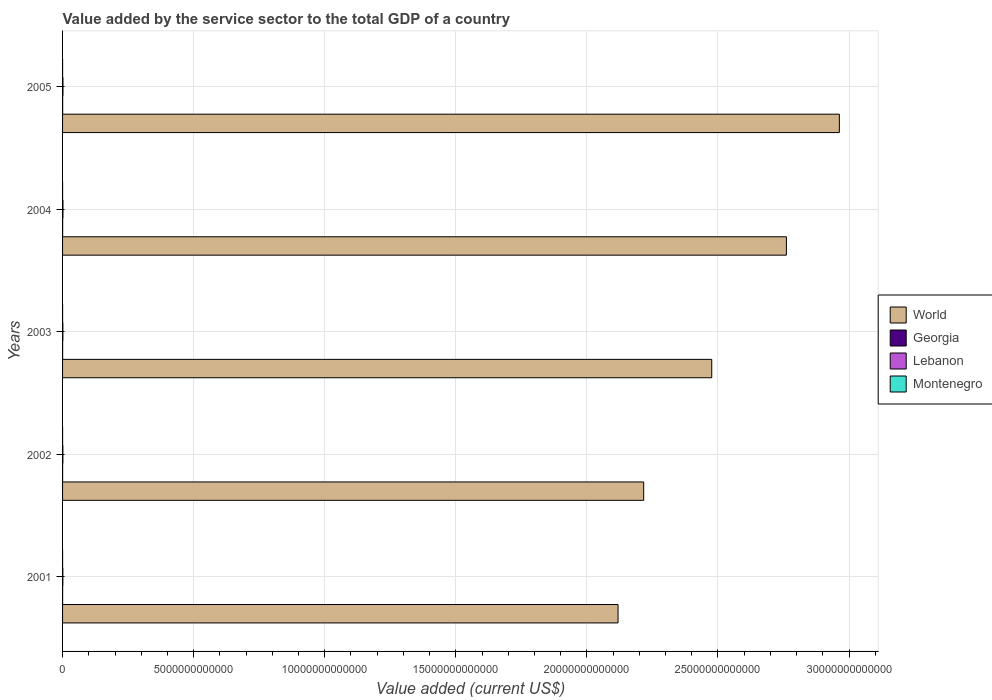How many groups of bars are there?
Offer a terse response. 5. Are the number of bars on each tick of the Y-axis equal?
Your answer should be very brief. Yes. How many bars are there on the 1st tick from the top?
Give a very brief answer. 4. How many bars are there on the 4th tick from the bottom?
Offer a very short reply. 4. What is the label of the 2nd group of bars from the top?
Give a very brief answer. 2004. In how many cases, is the number of bars for a given year not equal to the number of legend labels?
Provide a succinct answer. 0. What is the value added by the service sector to the total GDP in Georgia in 2001?
Your answer should be compact. 1.67e+09. Across all years, what is the maximum value added by the service sector to the total GDP in Georgia?
Offer a very short reply. 3.20e+09. Across all years, what is the minimum value added by the service sector to the total GDP in Lebanon?
Ensure brevity in your answer.  1.08e+1. In which year was the value added by the service sector to the total GDP in Lebanon maximum?
Keep it short and to the point. 2005. In which year was the value added by the service sector to the total GDP in Georgia minimum?
Provide a succinct answer. 2001. What is the total value added by the service sector to the total GDP in Lebanon in the graph?
Offer a very short reply. 6.41e+1. What is the difference between the value added by the service sector to the total GDP in Montenegro in 2001 and that in 2002?
Keep it short and to the point. -6.78e+07. What is the difference between the value added by the service sector to the total GDP in Lebanon in 2004 and the value added by the service sector to the total GDP in Montenegro in 2003?
Offer a terse response. 1.36e+1. What is the average value added by the service sector to the total GDP in Lebanon per year?
Ensure brevity in your answer.  1.28e+1. In the year 2002, what is the difference between the value added by the service sector to the total GDP in Lebanon and value added by the service sector to the total GDP in Montenegro?
Make the answer very short. 1.08e+1. In how many years, is the value added by the service sector to the total GDP in Montenegro greater than 19000000000000 US$?
Make the answer very short. 0. What is the ratio of the value added by the service sector to the total GDP in World in 2004 to that in 2005?
Your answer should be very brief. 0.93. What is the difference between the highest and the second highest value added by the service sector to the total GDP in World?
Make the answer very short. 2.02e+12. What is the difference between the highest and the lowest value added by the service sector to the total GDP in World?
Keep it short and to the point. 8.44e+12. In how many years, is the value added by the service sector to the total GDP in Lebanon greater than the average value added by the service sector to the total GDP in Lebanon taken over all years?
Your answer should be compact. 2. Is it the case that in every year, the sum of the value added by the service sector to the total GDP in World and value added by the service sector to the total GDP in Lebanon is greater than the sum of value added by the service sector to the total GDP in Montenegro and value added by the service sector to the total GDP in Georgia?
Ensure brevity in your answer.  Yes. What does the 4th bar from the bottom in 2003 represents?
Your response must be concise. Montenegro. How many bars are there?
Provide a succinct answer. 20. Are all the bars in the graph horizontal?
Provide a short and direct response. Yes. What is the difference between two consecutive major ticks on the X-axis?
Offer a terse response. 5.00e+12. Does the graph contain grids?
Make the answer very short. Yes. Where does the legend appear in the graph?
Your answer should be very brief. Center right. What is the title of the graph?
Your response must be concise. Value added by the service sector to the total GDP of a country. Does "Eritrea" appear as one of the legend labels in the graph?
Make the answer very short. No. What is the label or title of the X-axis?
Ensure brevity in your answer.  Value added (current US$). What is the label or title of the Y-axis?
Your response must be concise. Years. What is the Value added (current US$) of World in 2001?
Make the answer very short. 2.12e+13. What is the Value added (current US$) in Georgia in 2001?
Ensure brevity in your answer.  1.67e+09. What is the Value added (current US$) in Lebanon in 2001?
Provide a short and direct response. 1.08e+1. What is the Value added (current US$) of Montenegro in 2001?
Provide a short and direct response. 6.65e+08. What is the Value added (current US$) in World in 2002?
Keep it short and to the point. 2.22e+13. What is the Value added (current US$) of Georgia in 2002?
Offer a very short reply. 1.74e+09. What is the Value added (current US$) of Lebanon in 2002?
Give a very brief answer. 1.15e+1. What is the Value added (current US$) of Montenegro in 2002?
Offer a very short reply. 7.33e+08. What is the Value added (current US$) in World in 2003?
Your answer should be very brief. 2.48e+13. What is the Value added (current US$) in Georgia in 2003?
Offer a terse response. 2.02e+09. What is the Value added (current US$) of Lebanon in 2003?
Offer a very short reply. 1.20e+1. What is the Value added (current US$) in Montenegro in 2003?
Make the answer very short. 9.59e+08. What is the Value added (current US$) in World in 2004?
Ensure brevity in your answer.  2.76e+13. What is the Value added (current US$) of Georgia in 2004?
Your answer should be compact. 2.61e+09. What is the Value added (current US$) in Lebanon in 2004?
Provide a short and direct response. 1.45e+1. What is the Value added (current US$) in Montenegro in 2004?
Offer a terse response. 1.18e+09. What is the Value added (current US$) in World in 2005?
Give a very brief answer. 2.96e+13. What is the Value added (current US$) in Georgia in 2005?
Offer a terse response. 3.20e+09. What is the Value added (current US$) in Lebanon in 2005?
Provide a short and direct response. 1.52e+1. What is the Value added (current US$) in Montenegro in 2005?
Make the answer very short. 1.30e+09. Across all years, what is the maximum Value added (current US$) of World?
Provide a succinct answer. 2.96e+13. Across all years, what is the maximum Value added (current US$) of Georgia?
Provide a succinct answer. 3.20e+09. Across all years, what is the maximum Value added (current US$) of Lebanon?
Give a very brief answer. 1.52e+1. Across all years, what is the maximum Value added (current US$) of Montenegro?
Offer a terse response. 1.30e+09. Across all years, what is the minimum Value added (current US$) of World?
Offer a terse response. 2.12e+13. Across all years, what is the minimum Value added (current US$) in Georgia?
Provide a succinct answer. 1.67e+09. Across all years, what is the minimum Value added (current US$) in Lebanon?
Offer a terse response. 1.08e+1. Across all years, what is the minimum Value added (current US$) in Montenegro?
Your answer should be compact. 6.65e+08. What is the total Value added (current US$) in World in the graph?
Your response must be concise. 1.25e+14. What is the total Value added (current US$) of Georgia in the graph?
Ensure brevity in your answer.  1.12e+1. What is the total Value added (current US$) in Lebanon in the graph?
Offer a very short reply. 6.41e+1. What is the total Value added (current US$) of Montenegro in the graph?
Ensure brevity in your answer.  4.84e+09. What is the difference between the Value added (current US$) of World in 2001 and that in 2002?
Provide a short and direct response. -9.78e+11. What is the difference between the Value added (current US$) of Georgia in 2001 and that in 2002?
Ensure brevity in your answer.  -7.15e+07. What is the difference between the Value added (current US$) of Lebanon in 2001 and that in 2002?
Make the answer very short. -6.78e+08. What is the difference between the Value added (current US$) of Montenegro in 2001 and that in 2002?
Provide a short and direct response. -6.78e+07. What is the difference between the Value added (current US$) of World in 2001 and that in 2003?
Provide a short and direct response. -3.57e+12. What is the difference between the Value added (current US$) in Georgia in 2001 and that in 2003?
Make the answer very short. -3.43e+08. What is the difference between the Value added (current US$) of Lebanon in 2001 and that in 2003?
Offer a very short reply. -1.12e+09. What is the difference between the Value added (current US$) in Montenegro in 2001 and that in 2003?
Provide a succinct answer. -2.94e+08. What is the difference between the Value added (current US$) of World in 2001 and that in 2004?
Your answer should be very brief. -6.42e+12. What is the difference between the Value added (current US$) in Georgia in 2001 and that in 2004?
Keep it short and to the point. -9.37e+08. What is the difference between the Value added (current US$) in Lebanon in 2001 and that in 2004?
Your response must be concise. -3.69e+09. What is the difference between the Value added (current US$) in Montenegro in 2001 and that in 2004?
Keep it short and to the point. -5.14e+08. What is the difference between the Value added (current US$) in World in 2001 and that in 2005?
Ensure brevity in your answer.  -8.44e+12. What is the difference between the Value added (current US$) of Georgia in 2001 and that in 2005?
Offer a very short reply. -1.53e+09. What is the difference between the Value added (current US$) in Lebanon in 2001 and that in 2005?
Offer a very short reply. -4.37e+09. What is the difference between the Value added (current US$) in Montenegro in 2001 and that in 2005?
Your answer should be very brief. -6.36e+08. What is the difference between the Value added (current US$) of World in 2002 and that in 2003?
Offer a very short reply. -2.60e+12. What is the difference between the Value added (current US$) of Georgia in 2002 and that in 2003?
Offer a very short reply. -2.72e+08. What is the difference between the Value added (current US$) of Lebanon in 2002 and that in 2003?
Keep it short and to the point. -4.43e+08. What is the difference between the Value added (current US$) in Montenegro in 2002 and that in 2003?
Your answer should be very brief. -2.26e+08. What is the difference between the Value added (current US$) in World in 2002 and that in 2004?
Give a very brief answer. -5.44e+12. What is the difference between the Value added (current US$) in Georgia in 2002 and that in 2004?
Keep it short and to the point. -8.66e+08. What is the difference between the Value added (current US$) in Lebanon in 2002 and that in 2004?
Provide a succinct answer. -3.01e+09. What is the difference between the Value added (current US$) in Montenegro in 2002 and that in 2004?
Give a very brief answer. -4.46e+08. What is the difference between the Value added (current US$) of World in 2002 and that in 2005?
Your answer should be compact. -7.46e+12. What is the difference between the Value added (current US$) in Georgia in 2002 and that in 2005?
Ensure brevity in your answer.  -1.46e+09. What is the difference between the Value added (current US$) of Lebanon in 2002 and that in 2005?
Provide a short and direct response. -3.69e+09. What is the difference between the Value added (current US$) of Montenegro in 2002 and that in 2005?
Ensure brevity in your answer.  -5.68e+08. What is the difference between the Value added (current US$) in World in 2003 and that in 2004?
Provide a succinct answer. -2.85e+12. What is the difference between the Value added (current US$) in Georgia in 2003 and that in 2004?
Your answer should be compact. -5.94e+08. What is the difference between the Value added (current US$) of Lebanon in 2003 and that in 2004?
Provide a succinct answer. -2.57e+09. What is the difference between the Value added (current US$) in Montenegro in 2003 and that in 2004?
Provide a short and direct response. -2.20e+08. What is the difference between the Value added (current US$) in World in 2003 and that in 2005?
Your answer should be compact. -4.87e+12. What is the difference between the Value added (current US$) in Georgia in 2003 and that in 2005?
Make the answer very short. -1.19e+09. What is the difference between the Value added (current US$) in Lebanon in 2003 and that in 2005?
Give a very brief answer. -3.24e+09. What is the difference between the Value added (current US$) of Montenegro in 2003 and that in 2005?
Give a very brief answer. -3.42e+08. What is the difference between the Value added (current US$) of World in 2004 and that in 2005?
Make the answer very short. -2.02e+12. What is the difference between the Value added (current US$) in Georgia in 2004 and that in 2005?
Keep it short and to the point. -5.93e+08. What is the difference between the Value added (current US$) of Lebanon in 2004 and that in 2005?
Your response must be concise. -6.77e+08. What is the difference between the Value added (current US$) of Montenegro in 2004 and that in 2005?
Ensure brevity in your answer.  -1.22e+08. What is the difference between the Value added (current US$) of World in 2001 and the Value added (current US$) of Georgia in 2002?
Offer a terse response. 2.12e+13. What is the difference between the Value added (current US$) in World in 2001 and the Value added (current US$) in Lebanon in 2002?
Your answer should be compact. 2.12e+13. What is the difference between the Value added (current US$) in World in 2001 and the Value added (current US$) in Montenegro in 2002?
Offer a very short reply. 2.12e+13. What is the difference between the Value added (current US$) in Georgia in 2001 and the Value added (current US$) in Lebanon in 2002?
Offer a very short reply. -9.85e+09. What is the difference between the Value added (current US$) of Georgia in 2001 and the Value added (current US$) of Montenegro in 2002?
Offer a very short reply. 9.40e+08. What is the difference between the Value added (current US$) of Lebanon in 2001 and the Value added (current US$) of Montenegro in 2002?
Give a very brief answer. 1.01e+1. What is the difference between the Value added (current US$) in World in 2001 and the Value added (current US$) in Georgia in 2003?
Make the answer very short. 2.12e+13. What is the difference between the Value added (current US$) in World in 2001 and the Value added (current US$) in Lebanon in 2003?
Offer a terse response. 2.12e+13. What is the difference between the Value added (current US$) of World in 2001 and the Value added (current US$) of Montenegro in 2003?
Make the answer very short. 2.12e+13. What is the difference between the Value added (current US$) of Georgia in 2001 and the Value added (current US$) of Lebanon in 2003?
Offer a very short reply. -1.03e+1. What is the difference between the Value added (current US$) of Georgia in 2001 and the Value added (current US$) of Montenegro in 2003?
Your response must be concise. 7.14e+08. What is the difference between the Value added (current US$) of Lebanon in 2001 and the Value added (current US$) of Montenegro in 2003?
Offer a very short reply. 9.88e+09. What is the difference between the Value added (current US$) in World in 2001 and the Value added (current US$) in Georgia in 2004?
Your answer should be very brief. 2.12e+13. What is the difference between the Value added (current US$) in World in 2001 and the Value added (current US$) in Lebanon in 2004?
Provide a short and direct response. 2.12e+13. What is the difference between the Value added (current US$) of World in 2001 and the Value added (current US$) of Montenegro in 2004?
Keep it short and to the point. 2.12e+13. What is the difference between the Value added (current US$) in Georgia in 2001 and the Value added (current US$) in Lebanon in 2004?
Ensure brevity in your answer.  -1.29e+1. What is the difference between the Value added (current US$) of Georgia in 2001 and the Value added (current US$) of Montenegro in 2004?
Your answer should be compact. 4.94e+08. What is the difference between the Value added (current US$) in Lebanon in 2001 and the Value added (current US$) in Montenegro in 2004?
Your answer should be very brief. 9.66e+09. What is the difference between the Value added (current US$) in World in 2001 and the Value added (current US$) in Georgia in 2005?
Provide a short and direct response. 2.12e+13. What is the difference between the Value added (current US$) of World in 2001 and the Value added (current US$) of Lebanon in 2005?
Provide a short and direct response. 2.12e+13. What is the difference between the Value added (current US$) in World in 2001 and the Value added (current US$) in Montenegro in 2005?
Keep it short and to the point. 2.12e+13. What is the difference between the Value added (current US$) in Georgia in 2001 and the Value added (current US$) in Lebanon in 2005?
Your response must be concise. -1.35e+1. What is the difference between the Value added (current US$) of Georgia in 2001 and the Value added (current US$) of Montenegro in 2005?
Your answer should be compact. 3.72e+08. What is the difference between the Value added (current US$) in Lebanon in 2001 and the Value added (current US$) in Montenegro in 2005?
Provide a succinct answer. 9.54e+09. What is the difference between the Value added (current US$) in World in 2002 and the Value added (current US$) in Georgia in 2003?
Make the answer very short. 2.22e+13. What is the difference between the Value added (current US$) in World in 2002 and the Value added (current US$) in Lebanon in 2003?
Give a very brief answer. 2.22e+13. What is the difference between the Value added (current US$) in World in 2002 and the Value added (current US$) in Montenegro in 2003?
Your answer should be very brief. 2.22e+13. What is the difference between the Value added (current US$) of Georgia in 2002 and the Value added (current US$) of Lebanon in 2003?
Give a very brief answer. -1.02e+1. What is the difference between the Value added (current US$) in Georgia in 2002 and the Value added (current US$) in Montenegro in 2003?
Provide a succinct answer. 7.85e+08. What is the difference between the Value added (current US$) in Lebanon in 2002 and the Value added (current US$) in Montenegro in 2003?
Offer a very short reply. 1.06e+1. What is the difference between the Value added (current US$) in World in 2002 and the Value added (current US$) in Georgia in 2004?
Ensure brevity in your answer.  2.22e+13. What is the difference between the Value added (current US$) of World in 2002 and the Value added (current US$) of Lebanon in 2004?
Your response must be concise. 2.22e+13. What is the difference between the Value added (current US$) in World in 2002 and the Value added (current US$) in Montenegro in 2004?
Your response must be concise. 2.22e+13. What is the difference between the Value added (current US$) in Georgia in 2002 and the Value added (current US$) in Lebanon in 2004?
Keep it short and to the point. -1.28e+1. What is the difference between the Value added (current US$) of Georgia in 2002 and the Value added (current US$) of Montenegro in 2004?
Your answer should be compact. 5.65e+08. What is the difference between the Value added (current US$) in Lebanon in 2002 and the Value added (current US$) in Montenegro in 2004?
Ensure brevity in your answer.  1.03e+1. What is the difference between the Value added (current US$) in World in 2002 and the Value added (current US$) in Georgia in 2005?
Offer a very short reply. 2.22e+13. What is the difference between the Value added (current US$) in World in 2002 and the Value added (current US$) in Lebanon in 2005?
Ensure brevity in your answer.  2.22e+13. What is the difference between the Value added (current US$) of World in 2002 and the Value added (current US$) of Montenegro in 2005?
Your answer should be compact. 2.22e+13. What is the difference between the Value added (current US$) of Georgia in 2002 and the Value added (current US$) of Lebanon in 2005?
Offer a very short reply. -1.35e+1. What is the difference between the Value added (current US$) of Georgia in 2002 and the Value added (current US$) of Montenegro in 2005?
Give a very brief answer. 4.43e+08. What is the difference between the Value added (current US$) in Lebanon in 2002 and the Value added (current US$) in Montenegro in 2005?
Make the answer very short. 1.02e+1. What is the difference between the Value added (current US$) in World in 2003 and the Value added (current US$) in Georgia in 2004?
Your answer should be compact. 2.48e+13. What is the difference between the Value added (current US$) in World in 2003 and the Value added (current US$) in Lebanon in 2004?
Provide a short and direct response. 2.47e+13. What is the difference between the Value added (current US$) in World in 2003 and the Value added (current US$) in Montenegro in 2004?
Provide a short and direct response. 2.48e+13. What is the difference between the Value added (current US$) of Georgia in 2003 and the Value added (current US$) of Lebanon in 2004?
Make the answer very short. -1.25e+1. What is the difference between the Value added (current US$) in Georgia in 2003 and the Value added (current US$) in Montenegro in 2004?
Keep it short and to the point. 8.37e+08. What is the difference between the Value added (current US$) of Lebanon in 2003 and the Value added (current US$) of Montenegro in 2004?
Offer a terse response. 1.08e+1. What is the difference between the Value added (current US$) of World in 2003 and the Value added (current US$) of Georgia in 2005?
Your answer should be very brief. 2.48e+13. What is the difference between the Value added (current US$) of World in 2003 and the Value added (current US$) of Lebanon in 2005?
Offer a very short reply. 2.47e+13. What is the difference between the Value added (current US$) in World in 2003 and the Value added (current US$) in Montenegro in 2005?
Your answer should be compact. 2.48e+13. What is the difference between the Value added (current US$) in Georgia in 2003 and the Value added (current US$) in Lebanon in 2005?
Your answer should be compact. -1.32e+1. What is the difference between the Value added (current US$) in Georgia in 2003 and the Value added (current US$) in Montenegro in 2005?
Offer a terse response. 7.15e+08. What is the difference between the Value added (current US$) of Lebanon in 2003 and the Value added (current US$) of Montenegro in 2005?
Offer a terse response. 1.07e+1. What is the difference between the Value added (current US$) of World in 2004 and the Value added (current US$) of Georgia in 2005?
Give a very brief answer. 2.76e+13. What is the difference between the Value added (current US$) in World in 2004 and the Value added (current US$) in Lebanon in 2005?
Offer a terse response. 2.76e+13. What is the difference between the Value added (current US$) in World in 2004 and the Value added (current US$) in Montenegro in 2005?
Keep it short and to the point. 2.76e+13. What is the difference between the Value added (current US$) of Georgia in 2004 and the Value added (current US$) of Lebanon in 2005?
Your answer should be very brief. -1.26e+1. What is the difference between the Value added (current US$) in Georgia in 2004 and the Value added (current US$) in Montenegro in 2005?
Provide a short and direct response. 1.31e+09. What is the difference between the Value added (current US$) of Lebanon in 2004 and the Value added (current US$) of Montenegro in 2005?
Provide a succinct answer. 1.32e+1. What is the average Value added (current US$) in World per year?
Ensure brevity in your answer.  2.51e+13. What is the average Value added (current US$) of Georgia per year?
Your answer should be compact. 2.25e+09. What is the average Value added (current US$) in Lebanon per year?
Provide a succinct answer. 1.28e+1. What is the average Value added (current US$) of Montenegro per year?
Offer a very short reply. 9.68e+08. In the year 2001, what is the difference between the Value added (current US$) of World and Value added (current US$) of Georgia?
Keep it short and to the point. 2.12e+13. In the year 2001, what is the difference between the Value added (current US$) in World and Value added (current US$) in Lebanon?
Provide a short and direct response. 2.12e+13. In the year 2001, what is the difference between the Value added (current US$) in World and Value added (current US$) in Montenegro?
Provide a succinct answer. 2.12e+13. In the year 2001, what is the difference between the Value added (current US$) of Georgia and Value added (current US$) of Lebanon?
Make the answer very short. -9.17e+09. In the year 2001, what is the difference between the Value added (current US$) of Georgia and Value added (current US$) of Montenegro?
Provide a short and direct response. 1.01e+09. In the year 2001, what is the difference between the Value added (current US$) of Lebanon and Value added (current US$) of Montenegro?
Offer a very short reply. 1.02e+1. In the year 2002, what is the difference between the Value added (current US$) of World and Value added (current US$) of Georgia?
Offer a terse response. 2.22e+13. In the year 2002, what is the difference between the Value added (current US$) in World and Value added (current US$) in Lebanon?
Offer a very short reply. 2.22e+13. In the year 2002, what is the difference between the Value added (current US$) in World and Value added (current US$) in Montenegro?
Make the answer very short. 2.22e+13. In the year 2002, what is the difference between the Value added (current US$) in Georgia and Value added (current US$) in Lebanon?
Provide a short and direct response. -9.78e+09. In the year 2002, what is the difference between the Value added (current US$) in Georgia and Value added (current US$) in Montenegro?
Give a very brief answer. 1.01e+09. In the year 2002, what is the difference between the Value added (current US$) in Lebanon and Value added (current US$) in Montenegro?
Your answer should be compact. 1.08e+1. In the year 2003, what is the difference between the Value added (current US$) in World and Value added (current US$) in Georgia?
Your answer should be very brief. 2.48e+13. In the year 2003, what is the difference between the Value added (current US$) of World and Value added (current US$) of Lebanon?
Give a very brief answer. 2.48e+13. In the year 2003, what is the difference between the Value added (current US$) of World and Value added (current US$) of Montenegro?
Offer a very short reply. 2.48e+13. In the year 2003, what is the difference between the Value added (current US$) of Georgia and Value added (current US$) of Lebanon?
Keep it short and to the point. -9.95e+09. In the year 2003, what is the difference between the Value added (current US$) of Georgia and Value added (current US$) of Montenegro?
Offer a terse response. 1.06e+09. In the year 2003, what is the difference between the Value added (current US$) in Lebanon and Value added (current US$) in Montenegro?
Your response must be concise. 1.10e+1. In the year 2004, what is the difference between the Value added (current US$) of World and Value added (current US$) of Georgia?
Give a very brief answer. 2.76e+13. In the year 2004, what is the difference between the Value added (current US$) in World and Value added (current US$) in Lebanon?
Your response must be concise. 2.76e+13. In the year 2004, what is the difference between the Value added (current US$) of World and Value added (current US$) of Montenegro?
Give a very brief answer. 2.76e+13. In the year 2004, what is the difference between the Value added (current US$) in Georgia and Value added (current US$) in Lebanon?
Give a very brief answer. -1.19e+1. In the year 2004, what is the difference between the Value added (current US$) of Georgia and Value added (current US$) of Montenegro?
Your answer should be compact. 1.43e+09. In the year 2004, what is the difference between the Value added (current US$) in Lebanon and Value added (current US$) in Montenegro?
Your answer should be very brief. 1.34e+1. In the year 2005, what is the difference between the Value added (current US$) of World and Value added (current US$) of Georgia?
Ensure brevity in your answer.  2.96e+13. In the year 2005, what is the difference between the Value added (current US$) in World and Value added (current US$) in Lebanon?
Give a very brief answer. 2.96e+13. In the year 2005, what is the difference between the Value added (current US$) of World and Value added (current US$) of Montenegro?
Give a very brief answer. 2.96e+13. In the year 2005, what is the difference between the Value added (current US$) of Georgia and Value added (current US$) of Lebanon?
Make the answer very short. -1.20e+1. In the year 2005, what is the difference between the Value added (current US$) in Georgia and Value added (current US$) in Montenegro?
Your answer should be very brief. 1.90e+09. In the year 2005, what is the difference between the Value added (current US$) of Lebanon and Value added (current US$) of Montenegro?
Ensure brevity in your answer.  1.39e+1. What is the ratio of the Value added (current US$) of World in 2001 to that in 2002?
Give a very brief answer. 0.96. What is the ratio of the Value added (current US$) in Georgia in 2001 to that in 2002?
Give a very brief answer. 0.96. What is the ratio of the Value added (current US$) in Lebanon in 2001 to that in 2002?
Provide a short and direct response. 0.94. What is the ratio of the Value added (current US$) in Montenegro in 2001 to that in 2002?
Ensure brevity in your answer.  0.91. What is the ratio of the Value added (current US$) of World in 2001 to that in 2003?
Give a very brief answer. 0.86. What is the ratio of the Value added (current US$) in Georgia in 2001 to that in 2003?
Give a very brief answer. 0.83. What is the ratio of the Value added (current US$) in Lebanon in 2001 to that in 2003?
Offer a very short reply. 0.91. What is the ratio of the Value added (current US$) of Montenegro in 2001 to that in 2003?
Your response must be concise. 0.69. What is the ratio of the Value added (current US$) of World in 2001 to that in 2004?
Ensure brevity in your answer.  0.77. What is the ratio of the Value added (current US$) of Georgia in 2001 to that in 2004?
Provide a short and direct response. 0.64. What is the ratio of the Value added (current US$) of Lebanon in 2001 to that in 2004?
Your response must be concise. 0.75. What is the ratio of the Value added (current US$) in Montenegro in 2001 to that in 2004?
Your response must be concise. 0.56. What is the ratio of the Value added (current US$) of World in 2001 to that in 2005?
Your response must be concise. 0.72. What is the ratio of the Value added (current US$) in Georgia in 2001 to that in 2005?
Ensure brevity in your answer.  0.52. What is the ratio of the Value added (current US$) of Lebanon in 2001 to that in 2005?
Provide a succinct answer. 0.71. What is the ratio of the Value added (current US$) of Montenegro in 2001 to that in 2005?
Ensure brevity in your answer.  0.51. What is the ratio of the Value added (current US$) in World in 2002 to that in 2003?
Your answer should be compact. 0.9. What is the ratio of the Value added (current US$) in Georgia in 2002 to that in 2003?
Provide a short and direct response. 0.87. What is the ratio of the Value added (current US$) of Lebanon in 2002 to that in 2003?
Ensure brevity in your answer.  0.96. What is the ratio of the Value added (current US$) of Montenegro in 2002 to that in 2003?
Provide a short and direct response. 0.76. What is the ratio of the Value added (current US$) of World in 2002 to that in 2004?
Give a very brief answer. 0.8. What is the ratio of the Value added (current US$) in Georgia in 2002 to that in 2004?
Your answer should be very brief. 0.67. What is the ratio of the Value added (current US$) of Lebanon in 2002 to that in 2004?
Make the answer very short. 0.79. What is the ratio of the Value added (current US$) of Montenegro in 2002 to that in 2004?
Offer a terse response. 0.62. What is the ratio of the Value added (current US$) of World in 2002 to that in 2005?
Provide a short and direct response. 0.75. What is the ratio of the Value added (current US$) in Georgia in 2002 to that in 2005?
Ensure brevity in your answer.  0.54. What is the ratio of the Value added (current US$) in Lebanon in 2002 to that in 2005?
Offer a terse response. 0.76. What is the ratio of the Value added (current US$) of Montenegro in 2002 to that in 2005?
Offer a very short reply. 0.56. What is the ratio of the Value added (current US$) of World in 2003 to that in 2004?
Provide a short and direct response. 0.9. What is the ratio of the Value added (current US$) in Georgia in 2003 to that in 2004?
Make the answer very short. 0.77. What is the ratio of the Value added (current US$) of Lebanon in 2003 to that in 2004?
Your response must be concise. 0.82. What is the ratio of the Value added (current US$) in Montenegro in 2003 to that in 2004?
Ensure brevity in your answer.  0.81. What is the ratio of the Value added (current US$) in World in 2003 to that in 2005?
Ensure brevity in your answer.  0.84. What is the ratio of the Value added (current US$) in Georgia in 2003 to that in 2005?
Your response must be concise. 0.63. What is the ratio of the Value added (current US$) in Lebanon in 2003 to that in 2005?
Offer a terse response. 0.79. What is the ratio of the Value added (current US$) in Montenegro in 2003 to that in 2005?
Provide a succinct answer. 0.74. What is the ratio of the Value added (current US$) in World in 2004 to that in 2005?
Provide a succinct answer. 0.93. What is the ratio of the Value added (current US$) in Georgia in 2004 to that in 2005?
Offer a very short reply. 0.81. What is the ratio of the Value added (current US$) of Lebanon in 2004 to that in 2005?
Provide a succinct answer. 0.96. What is the ratio of the Value added (current US$) in Montenegro in 2004 to that in 2005?
Give a very brief answer. 0.91. What is the difference between the highest and the second highest Value added (current US$) in World?
Your answer should be compact. 2.02e+12. What is the difference between the highest and the second highest Value added (current US$) of Georgia?
Your answer should be compact. 5.93e+08. What is the difference between the highest and the second highest Value added (current US$) of Lebanon?
Your answer should be very brief. 6.77e+08. What is the difference between the highest and the second highest Value added (current US$) of Montenegro?
Your answer should be very brief. 1.22e+08. What is the difference between the highest and the lowest Value added (current US$) of World?
Make the answer very short. 8.44e+12. What is the difference between the highest and the lowest Value added (current US$) of Georgia?
Give a very brief answer. 1.53e+09. What is the difference between the highest and the lowest Value added (current US$) of Lebanon?
Ensure brevity in your answer.  4.37e+09. What is the difference between the highest and the lowest Value added (current US$) of Montenegro?
Your answer should be compact. 6.36e+08. 